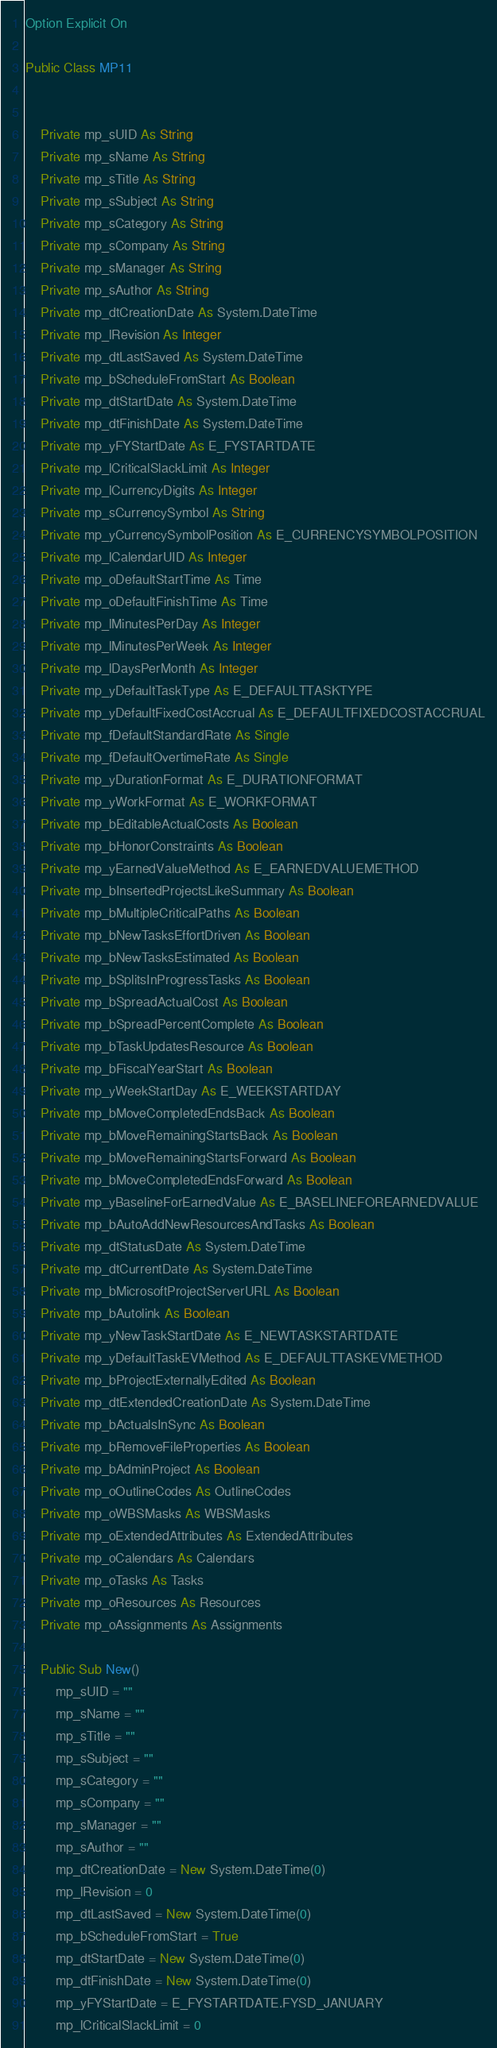Convert code to text. <code><loc_0><loc_0><loc_500><loc_500><_VisualBasic_>Option Explicit On

Public Class MP11


	Private mp_sUID As String
	Private mp_sName As String
	Private mp_sTitle As String
	Private mp_sSubject As String
	Private mp_sCategory As String
	Private mp_sCompany As String
	Private mp_sManager As String
	Private mp_sAuthor As String
	Private mp_dtCreationDate As System.DateTime
	Private mp_lRevision As Integer
	Private mp_dtLastSaved As System.DateTime
	Private mp_bScheduleFromStart As Boolean
	Private mp_dtStartDate As System.DateTime
	Private mp_dtFinishDate As System.DateTime
	Private mp_yFYStartDate As E_FYSTARTDATE
	Private mp_lCriticalSlackLimit As Integer
	Private mp_lCurrencyDigits As Integer
	Private mp_sCurrencySymbol As String
	Private mp_yCurrencySymbolPosition As E_CURRENCYSYMBOLPOSITION
	Private mp_lCalendarUID As Integer
	Private mp_oDefaultStartTime As Time
	Private mp_oDefaultFinishTime As Time
	Private mp_lMinutesPerDay As Integer
	Private mp_lMinutesPerWeek As Integer
	Private mp_lDaysPerMonth As Integer
	Private mp_yDefaultTaskType As E_DEFAULTTASKTYPE
	Private mp_yDefaultFixedCostAccrual As E_DEFAULTFIXEDCOSTACCRUAL
	Private mp_fDefaultStandardRate As Single
	Private mp_fDefaultOvertimeRate As Single
	Private mp_yDurationFormat As E_DURATIONFORMAT
	Private mp_yWorkFormat As E_WORKFORMAT
	Private mp_bEditableActualCosts As Boolean
	Private mp_bHonorConstraints As Boolean
	Private mp_yEarnedValueMethod As E_EARNEDVALUEMETHOD
	Private mp_bInsertedProjectsLikeSummary As Boolean
	Private mp_bMultipleCriticalPaths As Boolean
	Private mp_bNewTasksEffortDriven As Boolean
	Private mp_bNewTasksEstimated As Boolean
	Private mp_bSplitsInProgressTasks As Boolean
	Private mp_bSpreadActualCost As Boolean
	Private mp_bSpreadPercentComplete As Boolean
	Private mp_bTaskUpdatesResource As Boolean
	Private mp_bFiscalYearStart As Boolean
	Private mp_yWeekStartDay As E_WEEKSTARTDAY
	Private mp_bMoveCompletedEndsBack As Boolean
	Private mp_bMoveRemainingStartsBack As Boolean
	Private mp_bMoveRemainingStartsForward As Boolean
	Private mp_bMoveCompletedEndsForward As Boolean
	Private mp_yBaselineForEarnedValue As E_BASELINEFOREARNEDVALUE
	Private mp_bAutoAddNewResourcesAndTasks As Boolean
	Private mp_dtStatusDate As System.DateTime
	Private mp_dtCurrentDate As System.DateTime
	Private mp_bMicrosoftProjectServerURL As Boolean
	Private mp_bAutolink As Boolean
	Private mp_yNewTaskStartDate As E_NEWTASKSTARTDATE
	Private mp_yDefaultTaskEVMethod As E_DEFAULTTASKEVMETHOD
	Private mp_bProjectExternallyEdited As Boolean
	Private mp_dtExtendedCreationDate As System.DateTime
	Private mp_bActualsInSync As Boolean
	Private mp_bRemoveFileProperties As Boolean
	Private mp_bAdminProject As Boolean
	Private mp_oOutlineCodes As OutlineCodes
	Private mp_oWBSMasks As WBSMasks
	Private mp_oExtendedAttributes As ExtendedAttributes
	Private mp_oCalendars As Calendars
	Private mp_oTasks As Tasks
	Private mp_oResources As Resources
	Private mp_oAssignments As Assignments

	Public Sub New()
		mp_sUID = ""
		mp_sName = ""
		mp_sTitle = ""
		mp_sSubject = ""
		mp_sCategory = ""
		mp_sCompany = ""
		mp_sManager = ""
		mp_sAuthor = ""
		mp_dtCreationDate = New System.DateTime(0)
		mp_lRevision = 0
		mp_dtLastSaved = New System.DateTime(0)
		mp_bScheduleFromStart = True
		mp_dtStartDate = New System.DateTime(0)
		mp_dtFinishDate = New System.DateTime(0)
		mp_yFYStartDate = E_FYSTARTDATE.FYSD_JANUARY
		mp_lCriticalSlackLimit = 0</code> 